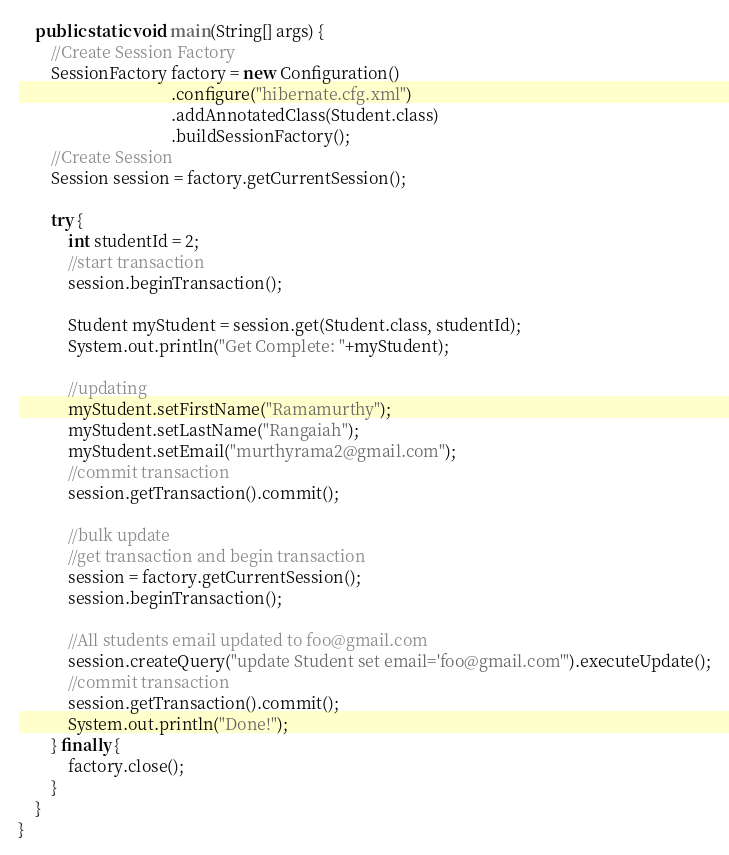<code> <loc_0><loc_0><loc_500><loc_500><_Java_>
	public static void main(String[] args) {
		//Create Session Factory
		SessionFactory factory = new Configuration()
									 .configure("hibernate.cfg.xml")
									 .addAnnotatedClass(Student.class)
									 .buildSessionFactory();
		//Create Session
		Session session = factory.getCurrentSession();
		
		try {
			int studentId = 2;
			//start transaction
			session.beginTransaction();
			
			Student myStudent = session.get(Student.class, studentId);
			System.out.println("Get Complete: "+myStudent);
			
			//updating
			myStudent.setFirstName("Ramamurthy");
			myStudent.setLastName("Rangaiah");
			myStudent.setEmail("murthyrama2@gmail.com");
			//commit transaction
			session.getTransaction().commit();
			
			//bulk update
			//get transaction and begin transaction
			session = factory.getCurrentSession();
			session.beginTransaction();
			
			//All students email updated to foo@gmail.com
			session.createQuery("update Student set email='foo@gmail.com'").executeUpdate();
			//commit transaction
			session.getTransaction().commit();
			System.out.println("Done!");
		} finally {
			factory.close();
		}
	}
}
</code> 